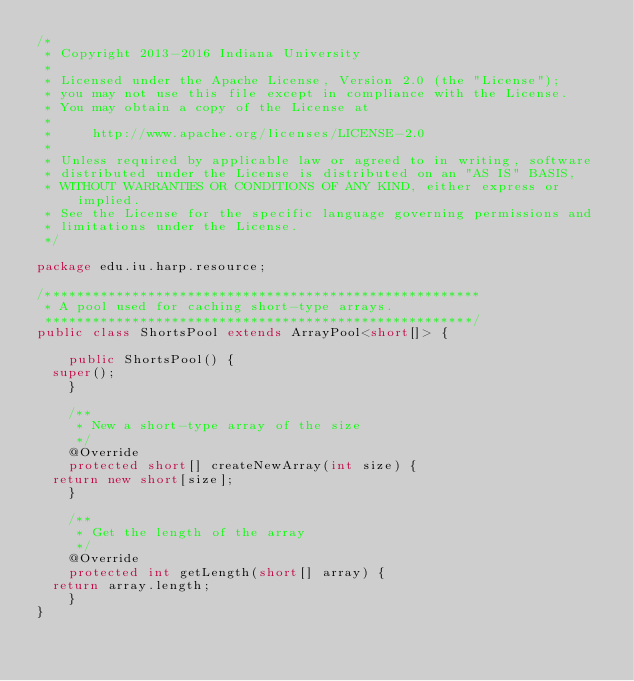Convert code to text. <code><loc_0><loc_0><loc_500><loc_500><_Java_>/*
 * Copyright 2013-2016 Indiana University
 * 
 * Licensed under the Apache License, Version 2.0 (the "License");
 * you may not use this file except in compliance with the License.
 * You may obtain a copy of the License at
 *
 *     http://www.apache.org/licenses/LICENSE-2.0
 *
 * Unless required by applicable law or agreed to in writing, software
 * distributed under the License is distributed on an "AS IS" BASIS,
 * WITHOUT WARRANTIES OR CONDITIONS OF ANY KIND, either express or implied.
 * See the License for the specific language governing permissions and
 * limitations under the License.
 */

package edu.iu.harp.resource;

/*******************************************************
 * A pool used for caching short-type arrays.
 ******************************************************/
public class ShortsPool extends ArrayPool<short[]> {

    public ShortsPool() {
	super();
    }

    /**
     * New a short-type array of the size
     */
    @Override
    protected short[] createNewArray(int size) {
	return new short[size];
    }

    /**
     * Get the length of the array
     */
    @Override
    protected int getLength(short[] array) {
	return array.length;
    }
}
</code> 